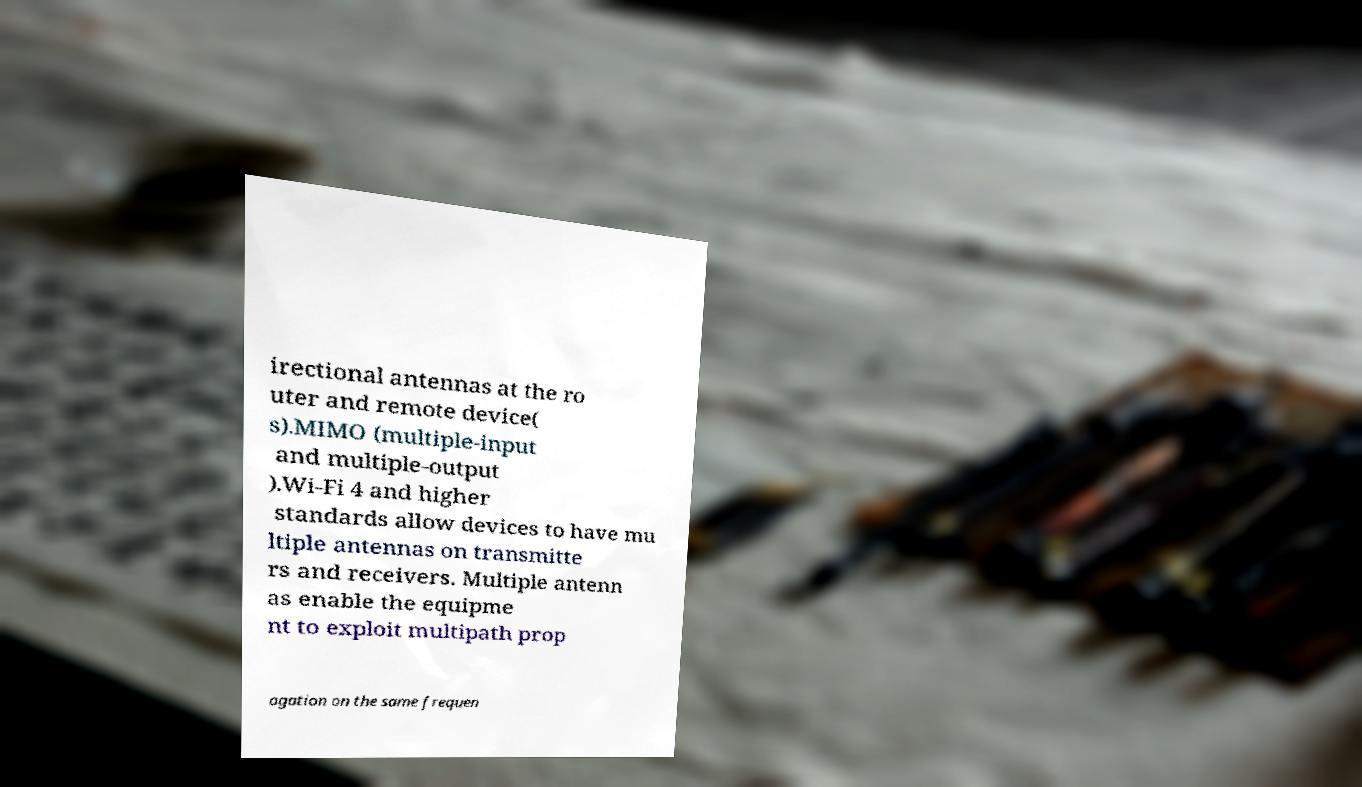I need the written content from this picture converted into text. Can you do that? irectional antennas at the ro uter and remote device( s).MIMO (multiple-input and multiple-output ).Wi-Fi 4 and higher standards allow devices to have mu ltiple antennas on transmitte rs and receivers. Multiple antenn as enable the equipme nt to exploit multipath prop agation on the same frequen 